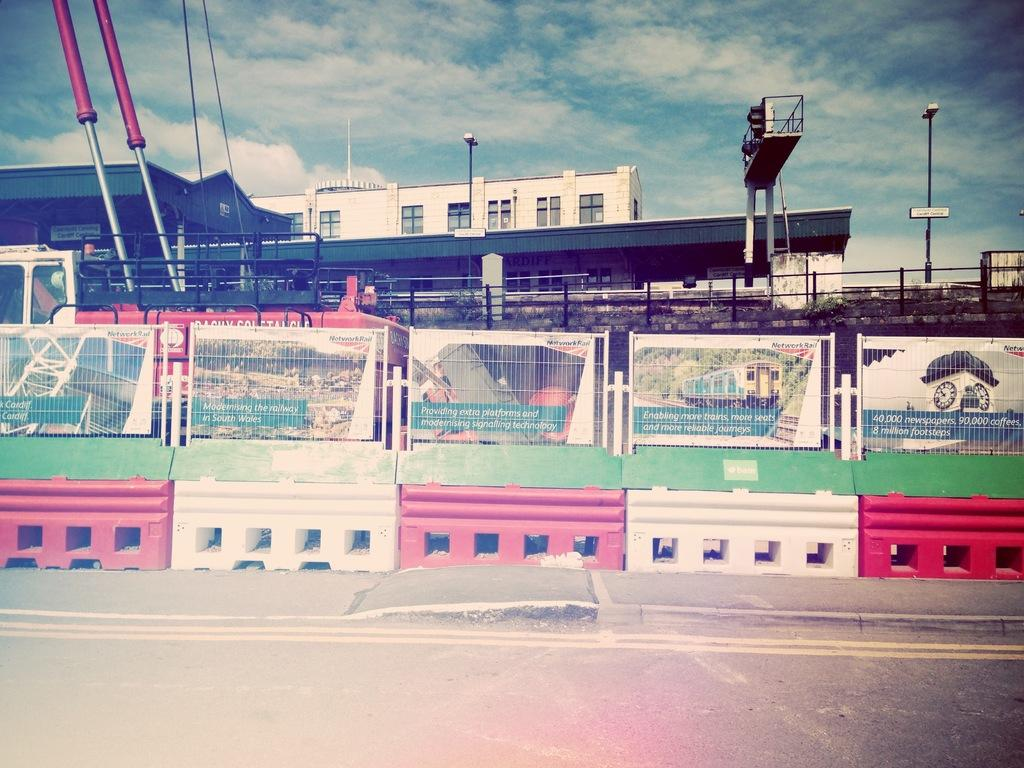What is located in the center of the image? There is a fencing and a road in the center of the image. What can be seen in the background of the image? There is a traffic signal, a vehicle, a building, a pole, the sky, and clouds in the background of the image. Where is the throne located in the image? There is no throne present in the image. How many clocks can be seen in the image? There are no clocks visible in the image. 